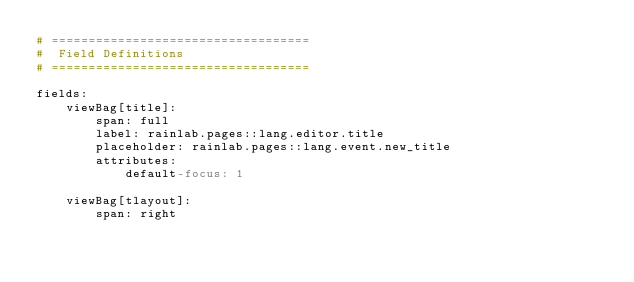Convert code to text. <code><loc_0><loc_0><loc_500><loc_500><_YAML_># ===================================
#  Field Definitions
# ===================================

fields:
    viewBag[title]:
        span: full
        label: rainlab.pages::lang.editor.title
        placeholder: rainlab.pages::lang.event.new_title
        attributes:
            default-focus: 1

    viewBag[tlayout]:
        span: right</code> 